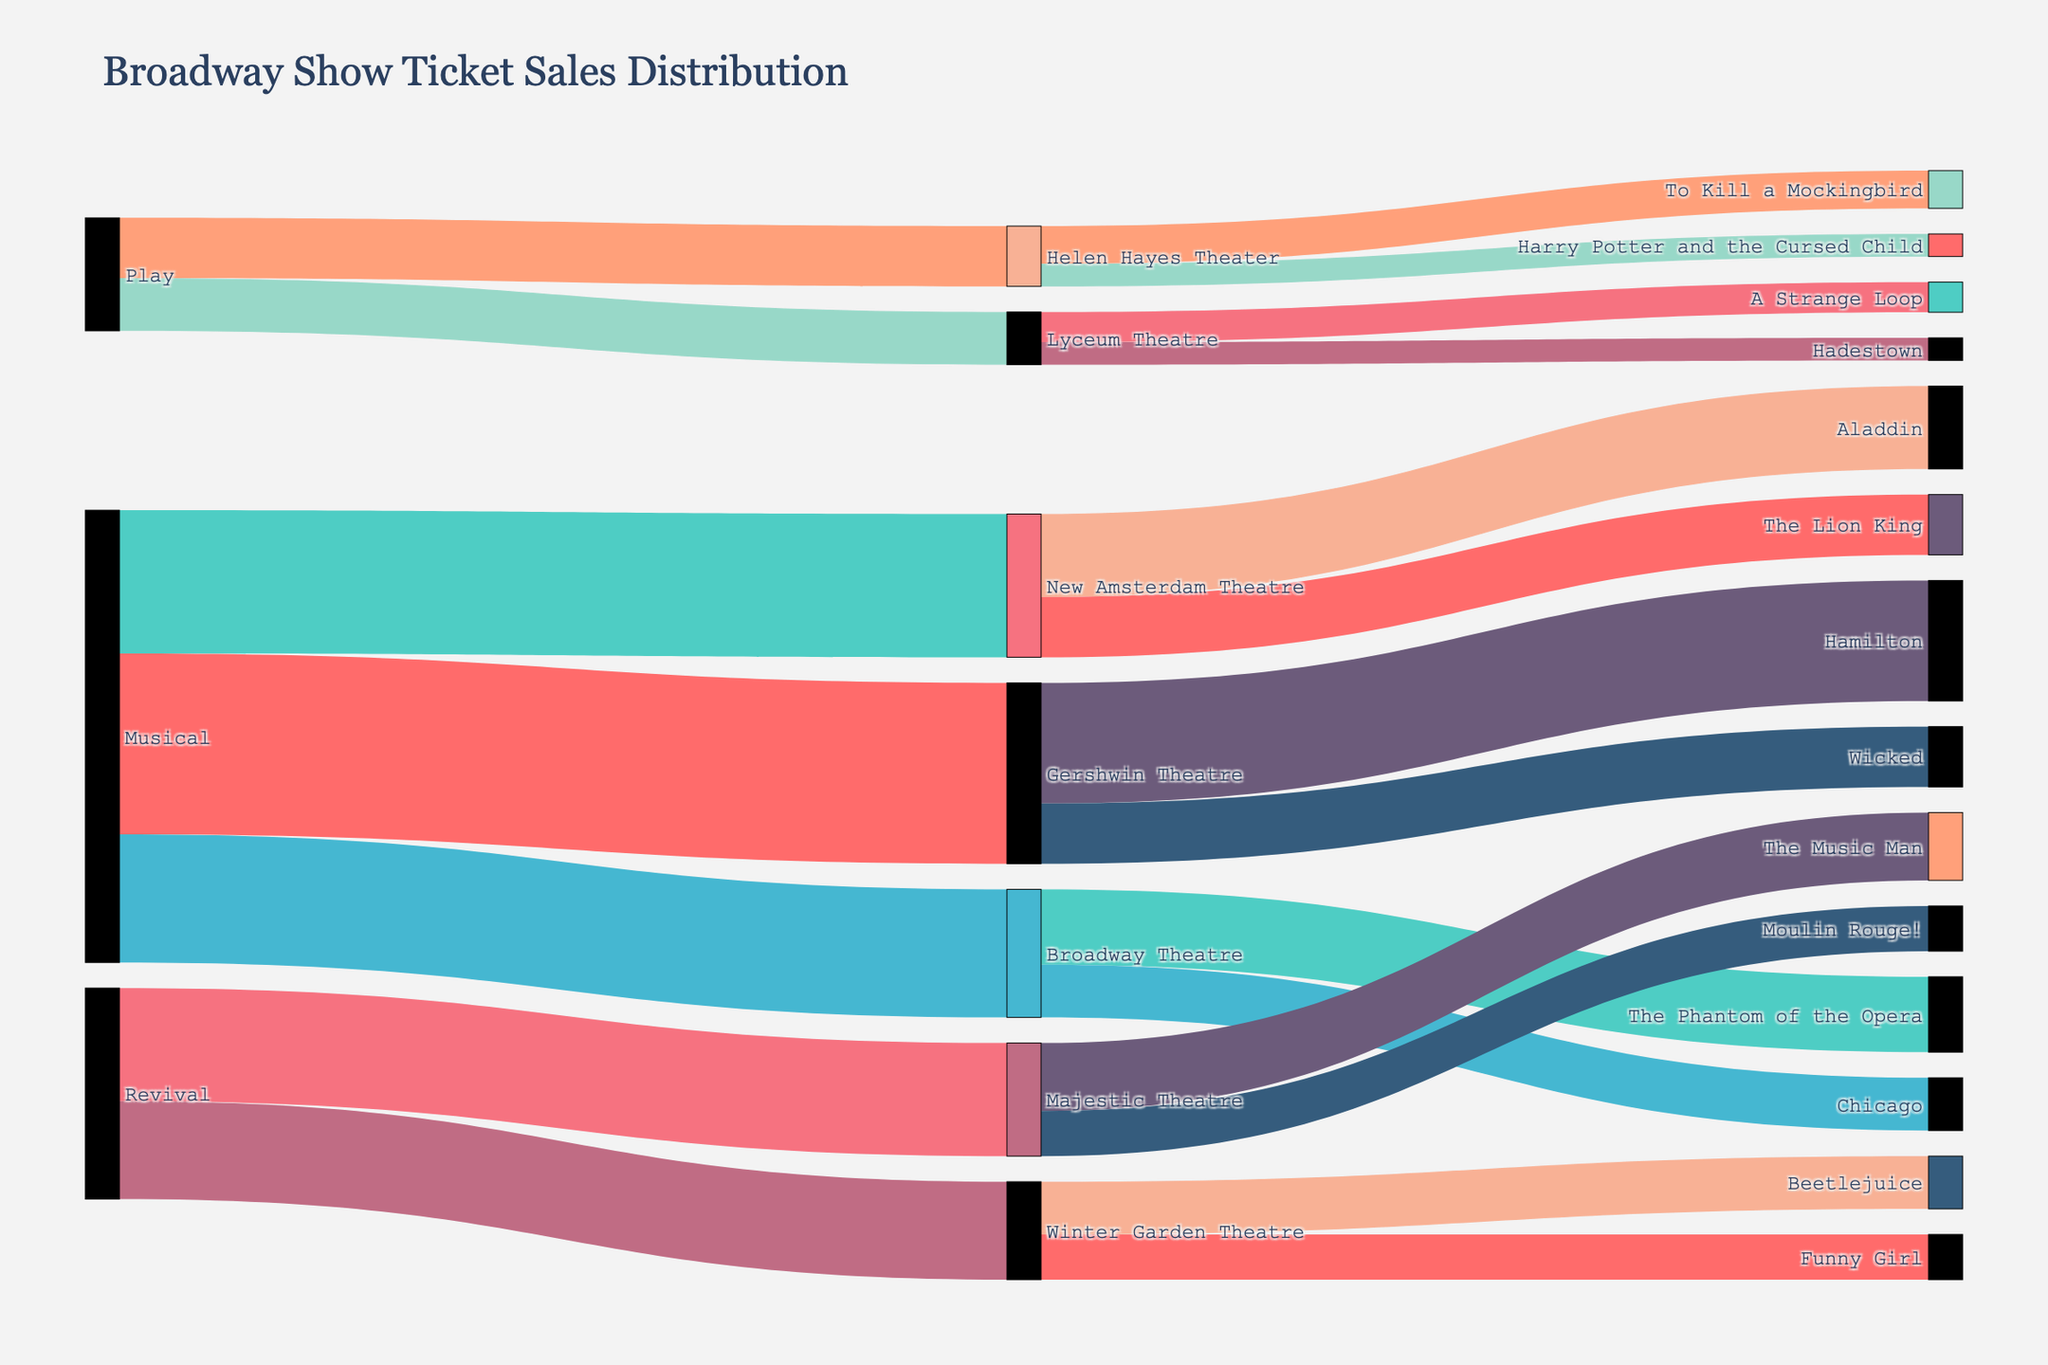What's the total number of tickets sold for musicals? Sum the values for all targets under the 'Musical' source. These are: Gershwin Theatre (1,200,000), New Amsterdam Theatre (950,000), Broadway Theatre (850,000). The total is 1,200,000 + 950,000 + 850,000 = 3,000,000.
Answer: 3,000,000 Which venue sold the most tickets for plays? Compare the ticket sales values for play venues: Helen Hayes Theater (400,000) and Lyceum Theatre (350,000). Helen Hayes Theater has the higher value.
Answer: Helen Hayes Theater What's the difference in ticket sales between 'The Music Man' and 'Moulin Rouge!' at Majestic Theatre? Subtract the value of 'Moulin Rouge!' (300,000) from 'The Music Man' (450,000). The difference is 450,000 - 300,000 = 150,000.
Answer: 150,000 What's the sum of ticket sales for revivals at Majestic Theatre and Winter Garden Theatre? Sum the values for both venues under the 'Revival' source. These are: Majestic Theatre (750,000) and Winter Garden Theatre (650,000). The total is 750,000 + 650,000 = 1,400,000.
Answer: 1,400,000 Which show has the highest ticket sales at Gershwin Theatre? Compare the ticket sales values for the shows at Gershwin Theatre: Hamilton (800,000) and Wicked (400,000). Hamilton has the higher value.
Answer: Hamilton How does the ticket sales for 'To Kill a Mockingbird' compare to 'Harry Potter and the Cursed Child' at Helen Hayes Theater? Compare their ticket sales values: To Kill a Mockingbird (250,000) and Harry Potter and the Cursed Child (150,000). To Kill a Mockingbird has higher sales.
Answer: To Kill a Mockingbird What's the average ticket sales for musicals at Broadway Theatre? Sum the values for all musical shows at Broadway Theatre: The Phantom of the Opera (500,000) and Chicago (350,000). Then, divide by the number of shows: (500,000 + 350,000) / 2 = 425,000.
Answer: 425,000 How do ticket sales for 'The Lion King' at New Amsterdam Theatre compare to 'Aladdin' at the same venue? Compare their ticket sales values: The Lion King (400,000) and Aladdin (550,000). Aladdin has higher sales.
Answer: Aladdin What's the combined ticket sales for 'Beetlejuice' and 'Funny Girl' at Winter Garden Theatre? Sum the values for both shows: Beetlejuice (350,000) and Funny Girl (300,000). The total is 350,000 + 300,000 = 650,000.
Answer: 650,000 